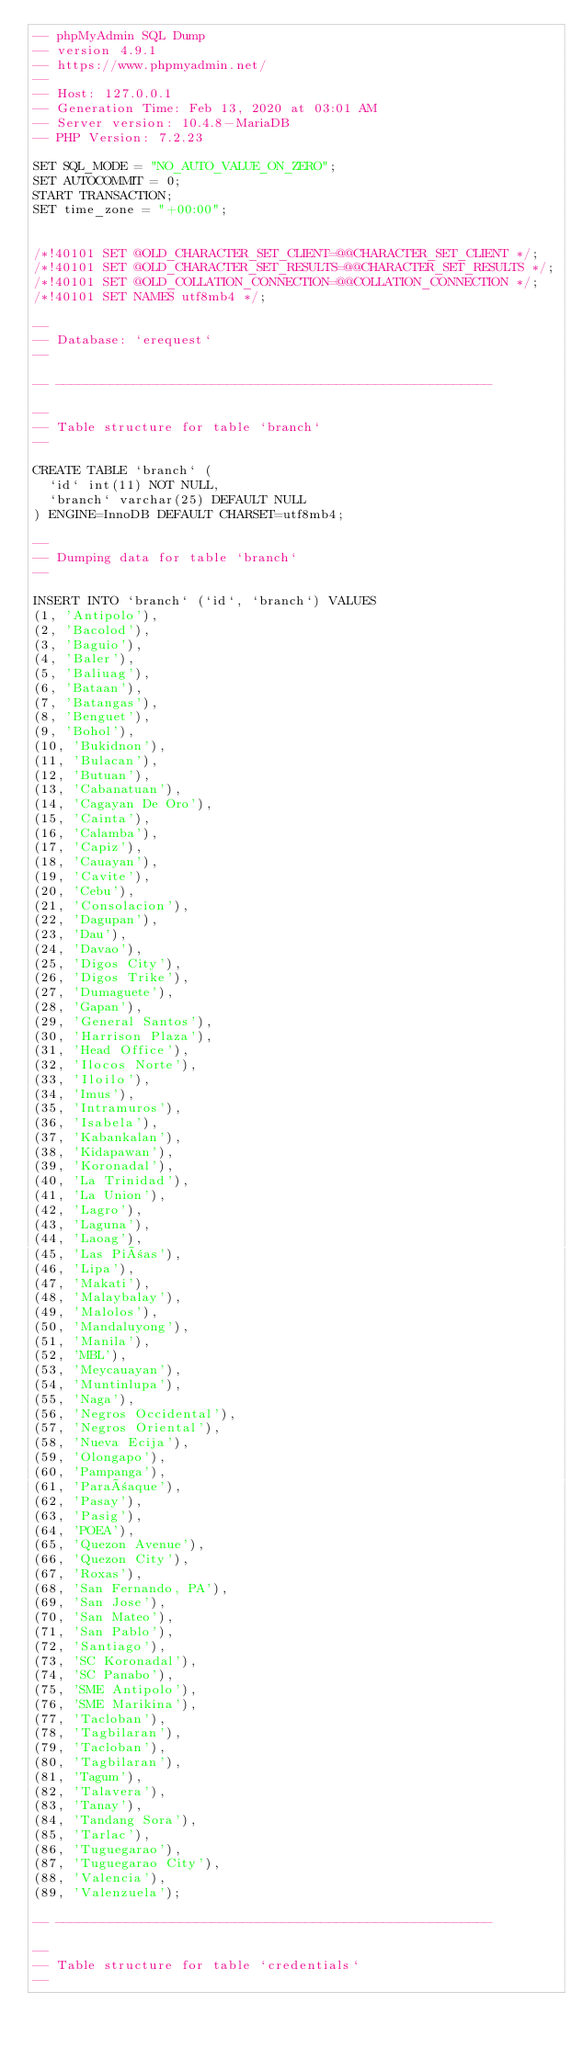<code> <loc_0><loc_0><loc_500><loc_500><_SQL_>-- phpMyAdmin SQL Dump
-- version 4.9.1
-- https://www.phpmyadmin.net/
--
-- Host: 127.0.0.1
-- Generation Time: Feb 13, 2020 at 03:01 AM
-- Server version: 10.4.8-MariaDB
-- PHP Version: 7.2.23

SET SQL_MODE = "NO_AUTO_VALUE_ON_ZERO";
SET AUTOCOMMIT = 0;
START TRANSACTION;
SET time_zone = "+00:00";


/*!40101 SET @OLD_CHARACTER_SET_CLIENT=@@CHARACTER_SET_CLIENT */;
/*!40101 SET @OLD_CHARACTER_SET_RESULTS=@@CHARACTER_SET_RESULTS */;
/*!40101 SET @OLD_COLLATION_CONNECTION=@@COLLATION_CONNECTION */;
/*!40101 SET NAMES utf8mb4 */;

--
-- Database: `erequest`
--

-- --------------------------------------------------------

--
-- Table structure for table `branch`
--

CREATE TABLE `branch` (
  `id` int(11) NOT NULL,
  `branch` varchar(25) DEFAULT NULL
) ENGINE=InnoDB DEFAULT CHARSET=utf8mb4;

--
-- Dumping data for table `branch`
--

INSERT INTO `branch` (`id`, `branch`) VALUES
(1, 'Antipolo'),
(2, 'Bacolod'),
(3, 'Baguio'),
(4, 'Baler'),
(5, 'Baliuag'),
(6, 'Bataan'),
(7, 'Batangas'),
(8, 'Benguet'),
(9, 'Bohol'),
(10, 'Bukidnon'),
(11, 'Bulacan'),
(12, 'Butuan'),
(13, 'Cabanatuan'),
(14, 'Cagayan De Oro'),
(15, 'Cainta'),
(16, 'Calamba'),
(17, 'Capiz'),
(18, 'Cauayan'),
(19, 'Cavite'),
(20, 'Cebu'),
(21, 'Consolacion'),
(22, 'Dagupan'),
(23, 'Dau'),
(24, 'Davao'),
(25, 'Digos City'),
(26, 'Digos Trike'),
(27, 'Dumaguete'),
(28, 'Gapan'),
(29, 'General Santos'),
(30, 'Harrison Plaza'),
(31, 'Head Office'),
(32, 'Ilocos Norte'),
(33, 'Iloilo'),
(34, 'Imus'),
(35, 'Intramuros'),
(36, 'Isabela'),
(37, 'Kabankalan'),
(38, 'Kidapawan'),
(39, 'Koronadal'),
(40, 'La Trinidad'),
(41, 'La Union'),
(42, 'Lagro'),
(43, 'Laguna'),
(44, 'Laoag'),
(45, 'Las Piñas'),
(46, 'Lipa'),
(47, 'Makati'),
(48, 'Malaybalay'),
(49, 'Malolos'),
(50, 'Mandaluyong'),
(51, 'Manila'),
(52, 'MBL'),
(53, 'Meycauayan'),
(54, 'Muntinlupa'),
(55, 'Naga'),
(56, 'Negros Occidental'),
(57, 'Negros Oriental'),
(58, 'Nueva Ecija'),
(59, 'Olongapo'),
(60, 'Pampanga'),
(61, 'Parañaque'),
(62, 'Pasay'),
(63, 'Pasig'),
(64, 'POEA'),
(65, 'Quezon Avenue'),
(66, 'Quezon City'),
(67, 'Roxas'),
(68, 'San Fernando, PA'),
(69, 'San Jose'),
(70, 'San Mateo'),
(71, 'San Pablo'),
(72, 'Santiago'),
(73, 'SC Koronadal'),
(74, 'SC Panabo'),
(75, 'SME Antipolo'),
(76, 'SME Marikina'),
(77, 'Tacloban'),
(78, 'Tagbilaran'),
(79, 'Tacloban'),
(80, 'Tagbilaran'),
(81, 'Tagum'),
(82, 'Talavera'),
(83, 'Tanay'),
(84, 'Tandang Sora'),
(85, 'Tarlac'),
(86, 'Tuguegarao'),
(87, 'Tuguegarao City'),
(88, 'Valencia'),
(89, 'Valenzuela');

-- --------------------------------------------------------

--
-- Table structure for table `credentials`
--
</code> 